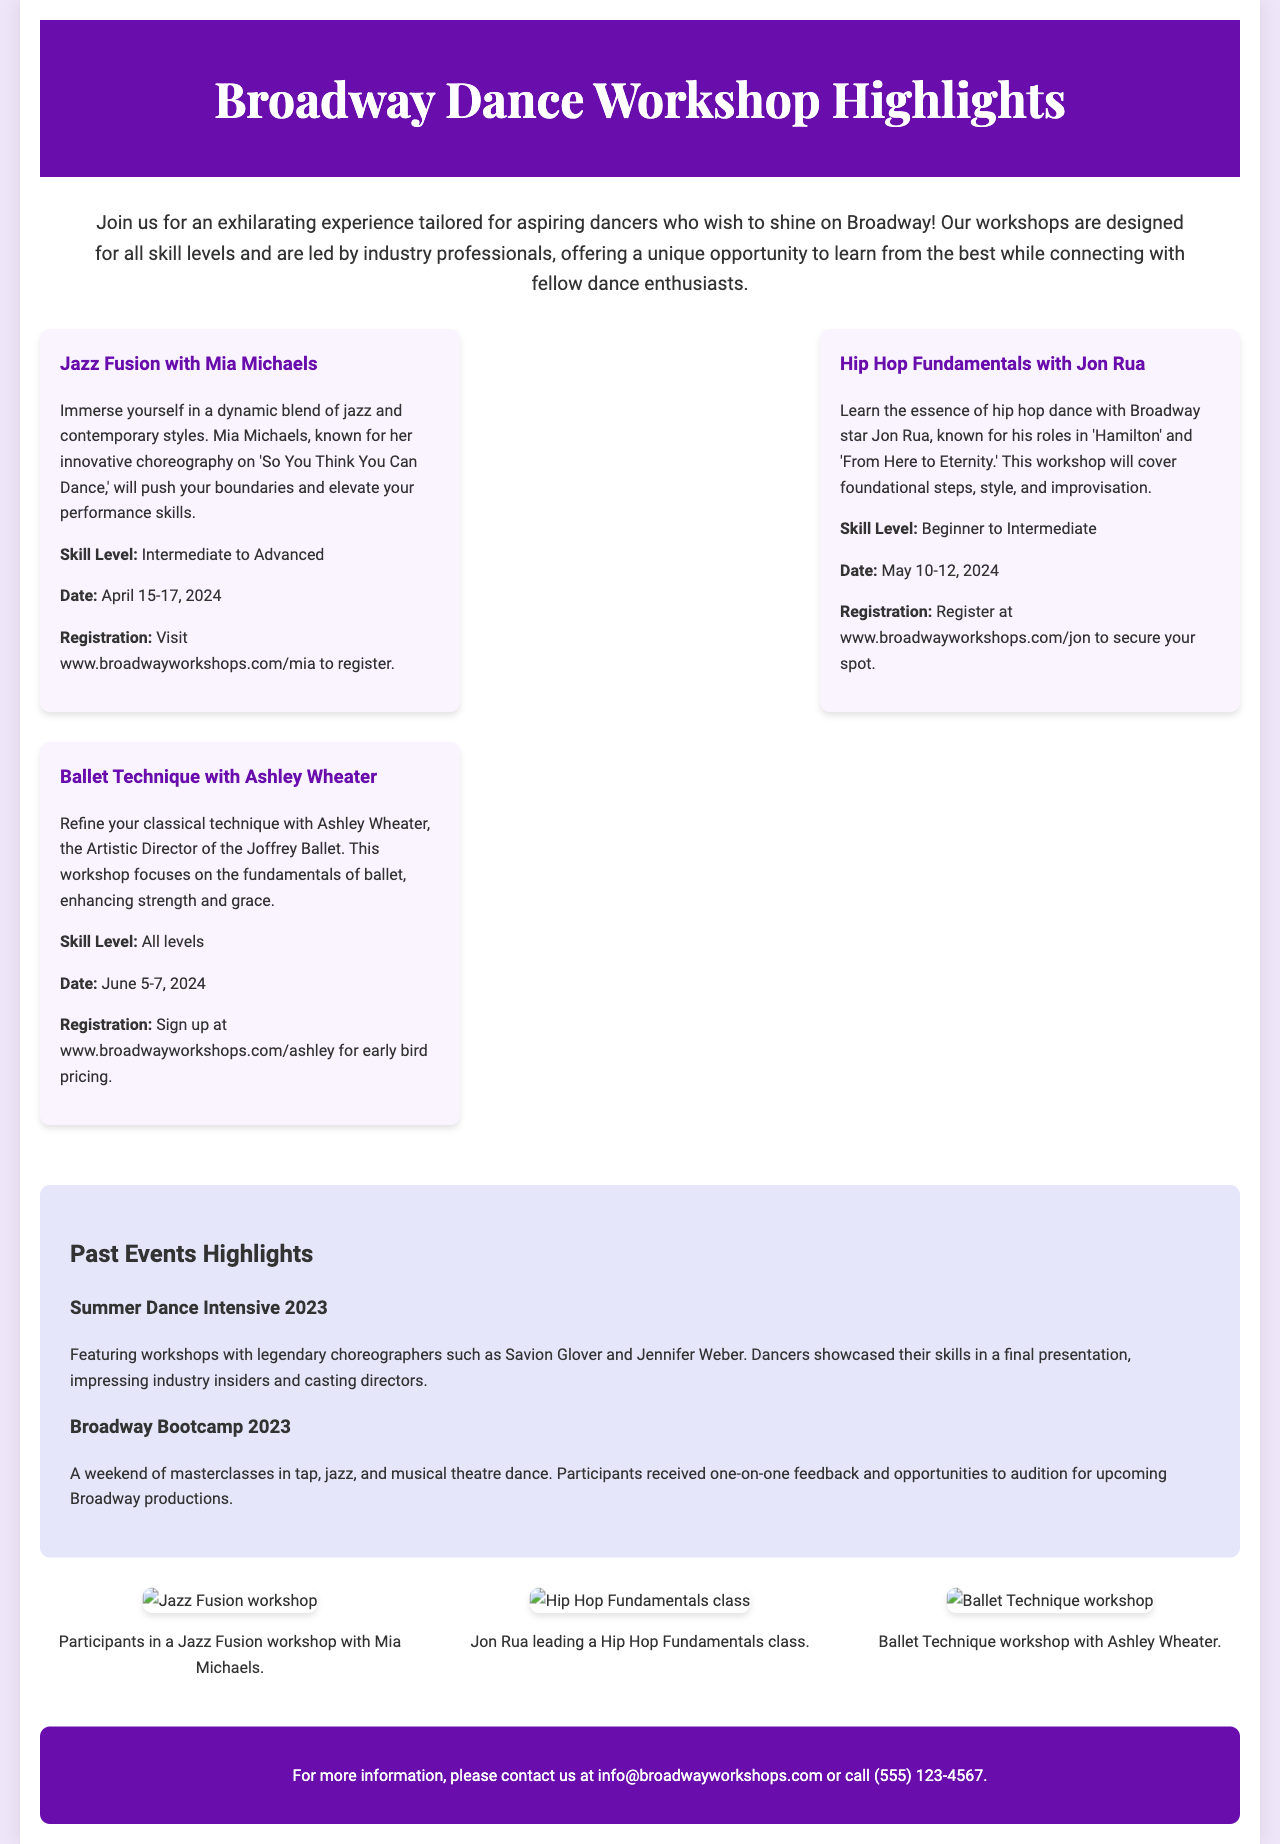What is the title of the brochure? The title is prominently displayed at the top of the document, which is "Broadway Dance Workshop Highlights."
Answer: Broadway Dance Workshop Highlights Who is the guest instructor for the Jazz Fusion workshop? The guest instructor for the Jazz Fusion workshop is mentioned in the description of that workshop, which is Mia Michaels.
Answer: Mia Michaels What is the skill level for the Ballet Technique workshop? The skill level for the Ballet Technique workshop is specified in the workshop details, which is "All levels."
Answer: All levels When is the Hip Hop Fundamentals workshop scheduled? The date for the Hip Hop Fundamentals workshop is provided in the workshop details, which is May 10-12, 2024.
Answer: May 10-12, 2024 What kind of dance is focused on in the workshop with Jon Rua? The type of dance covered in the workshop with Jon Rua is described in the workshop details, which is Hip Hop.
Answer: Hip Hop What was a highlight of the Summer Dance Intensive 2023? The highlight mentioned for the Summer Dance Intensive 2023 is that dancers showcased their skills in a final presentation, impressing industry insiders.
Answer: Final presentation How can one register for the Jazz Fusion workshop? The registration details for the Jazz Fusion workshop are provided, stating to visit a specific website to register.
Answer: Visit www.broadwayworkshops.com/mia What is included in the vibrant images section? The vibrant images section includes pictures from past events and their corresponding descriptions, highlighting workshop participation.
Answer: Pictures from past events Who to contact for more information? The contact information provided at the bottom section specifies an email address and a phone number for inquiries.
Answer: info@broadwayworkshops.com 